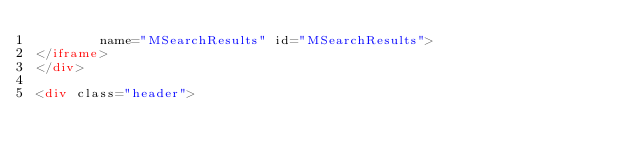<code> <loc_0><loc_0><loc_500><loc_500><_HTML_>        name="MSearchResults" id="MSearchResults">
</iframe>
</div>

<div class="header"></code> 